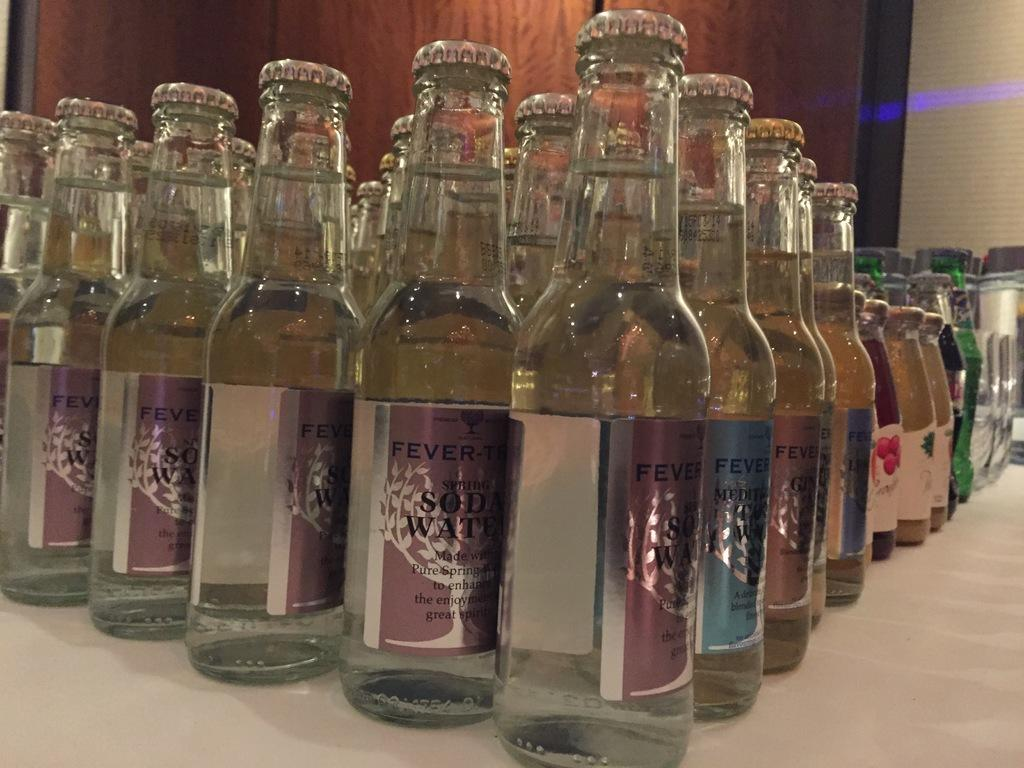What is the primary subject of the image? The primary subject of the image is many bottles. What is inside the bottles? The bottles contain liquid. How many sisters are depicted interacting with the railway in the image? There is no railway or sisters present in the image; it only features bottles containing liquid. 